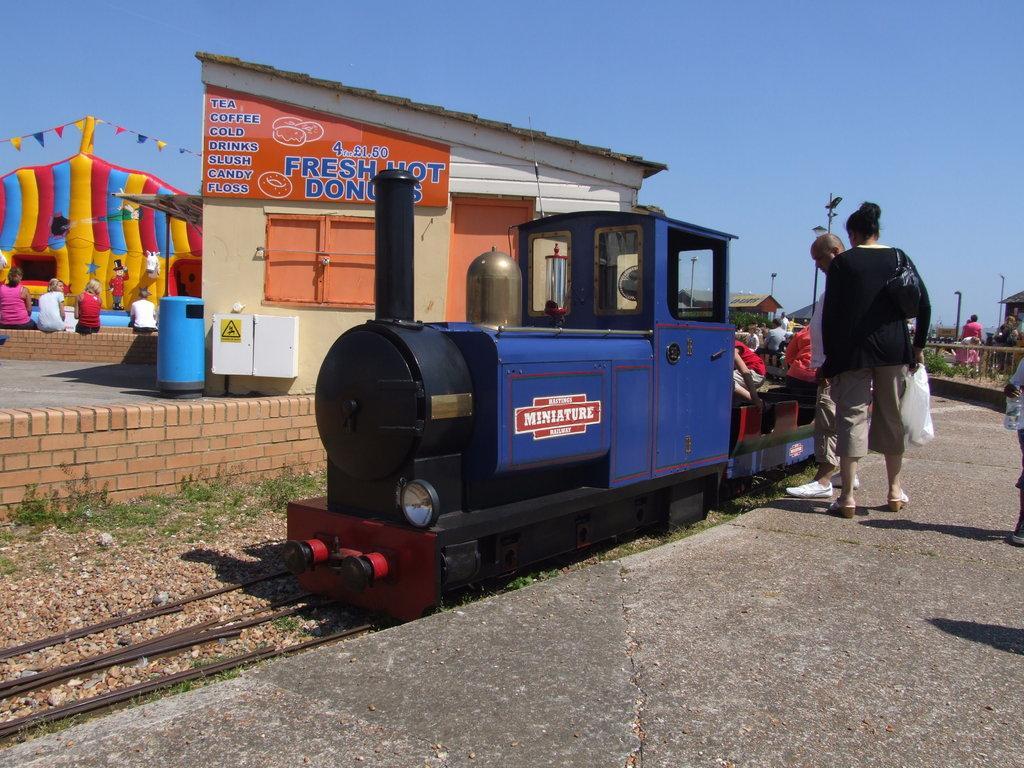Describe this image in one or two sentences. In this picture we can see a train on the track. Here we can see few persons, bin, boxes, poles, fence, plants, sheds, board, flags, and an object. In the background there is sky. 